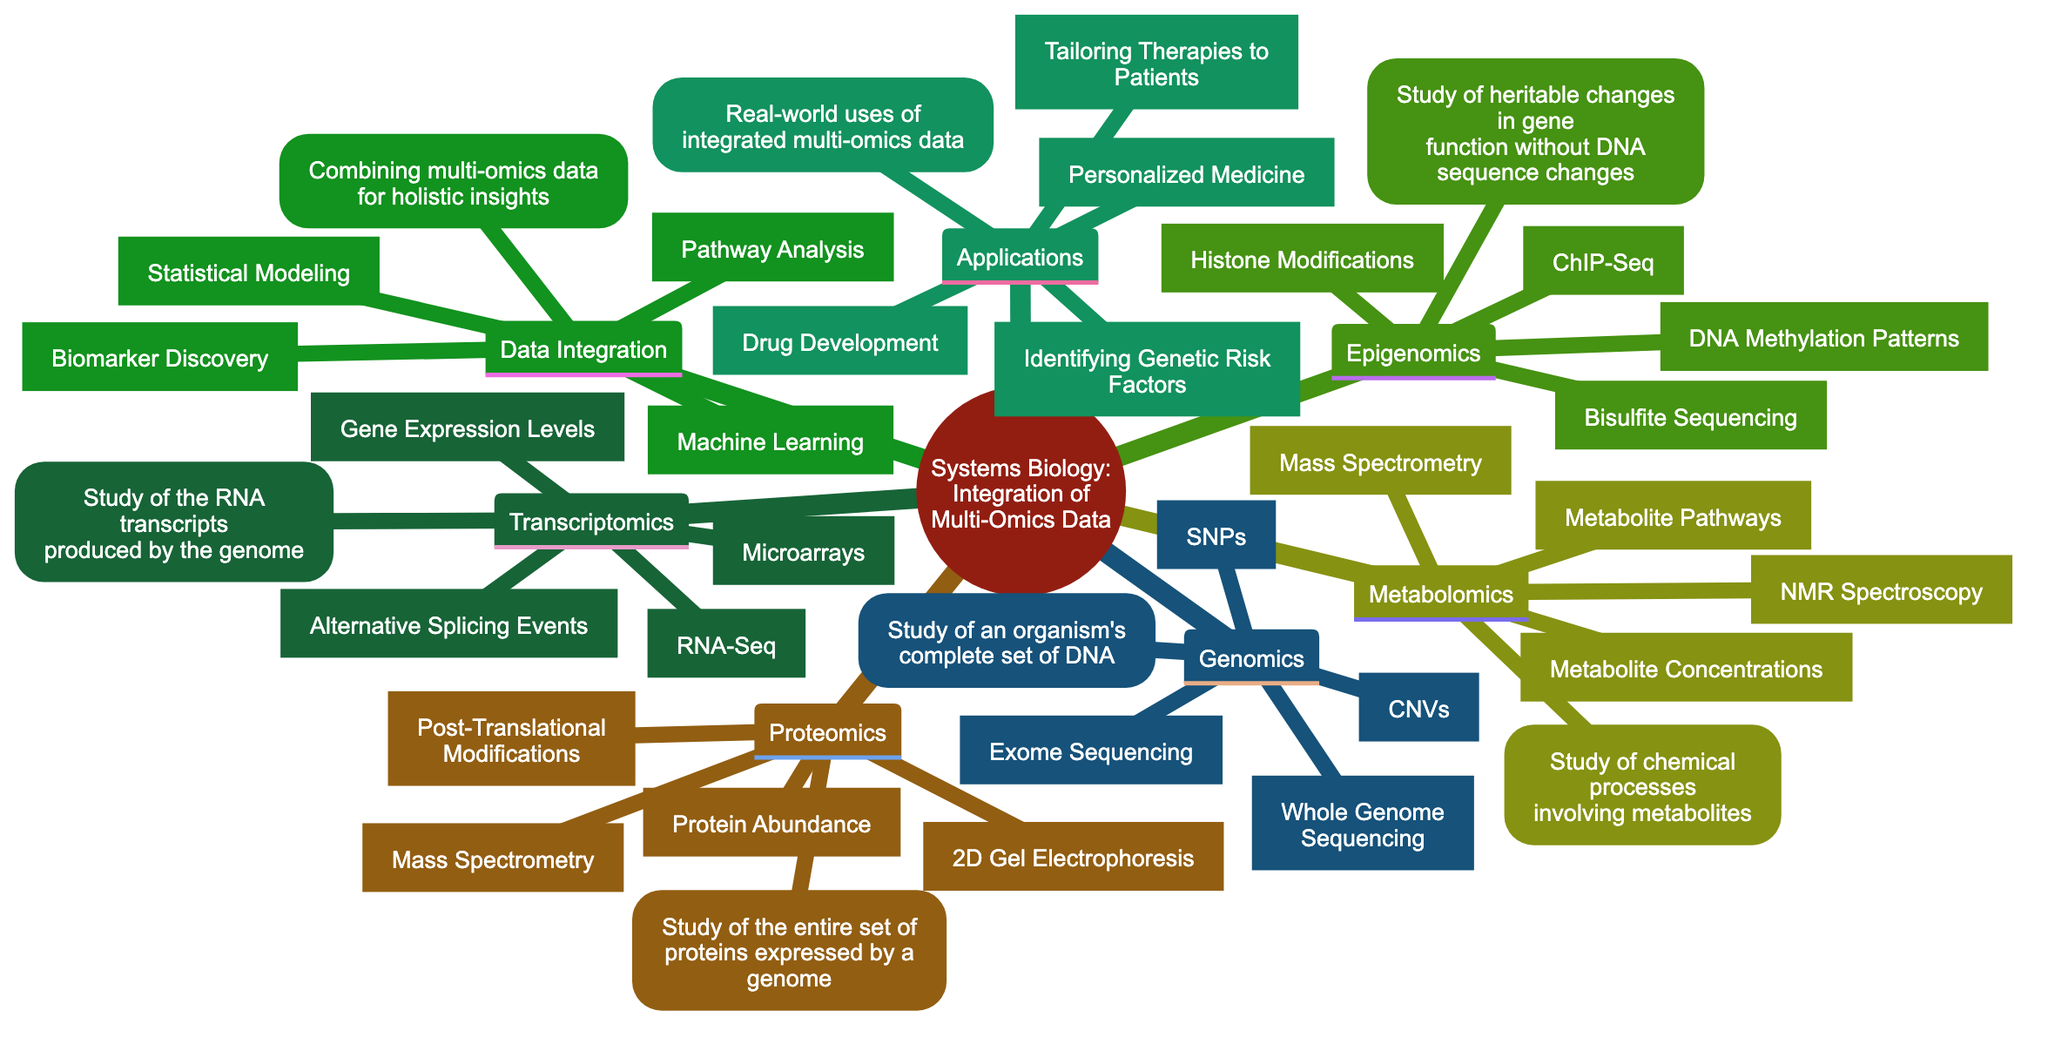What is the main topic of the concept map? The main topic can be found at the root node of the diagram, which states "Systems Biology: Integration of Multi-Omics Data."
Answer: Systems Biology: Integration of Multi-Omics Data How many subtopics are there under the main topic? Counting the subtopics listed below the main topic, we identify six: Genomics, Transcriptomics, Proteomics, Metabolomics, Epigenomics, and Data Integration.
Answer: Six What are two key techniques used in Transcriptomics? By examining the subtopic "Transcriptomics," we see it lists two key techniques: "RNA-Seq" and "Microarrays."
Answer: RNA-Seq, Microarrays What type of data is studied in Proteomics? In the subtopic "Proteomics," the data mentioned includes "Protein Abundance" and "Post-Translational Modifications."
Answer: Protein Abundance, Post-Translational Modifications What outcomes are associated with Data Integration? The "Data Integration" subtopic provides two key outcomes: "Biomarker Discovery" and "Pathway Analysis."
Answer: Biomarker Discovery, Pathway Analysis Which area is associated with the real-world applications of integrated multi-omics data? The subtopic "Applications" highlights the areas, including "Personalized Medicine" and "Drug Development," indicating their real-world relevance.
Answer: Personalized Medicine, Drug Development Which key technique is common between Metabolomics and Proteomics? Looking at both the "Metabolomics" and "Proteomics" subtopics, "Mass Spectrometry" is a key technique mentioned in both areas.
Answer: Mass Spectrometry What is the focus of Epigenomics as described in the diagram? The subtopic "Epigenomics" discusses heritable changes in gene function that don't involve alterations in the DNA sequence, indicating its focus on these modifications.
Answer: Heritable changes in gene function What do the techniques listed under Data Integration aim to achieve? The techniques "Statistical Modeling" and "Machine Learning" under "Data Integration" aim to combine multi-omics data to provide holistic insights, primarily for outcomes like biomarker discovery.
Answer: Holistic insights 